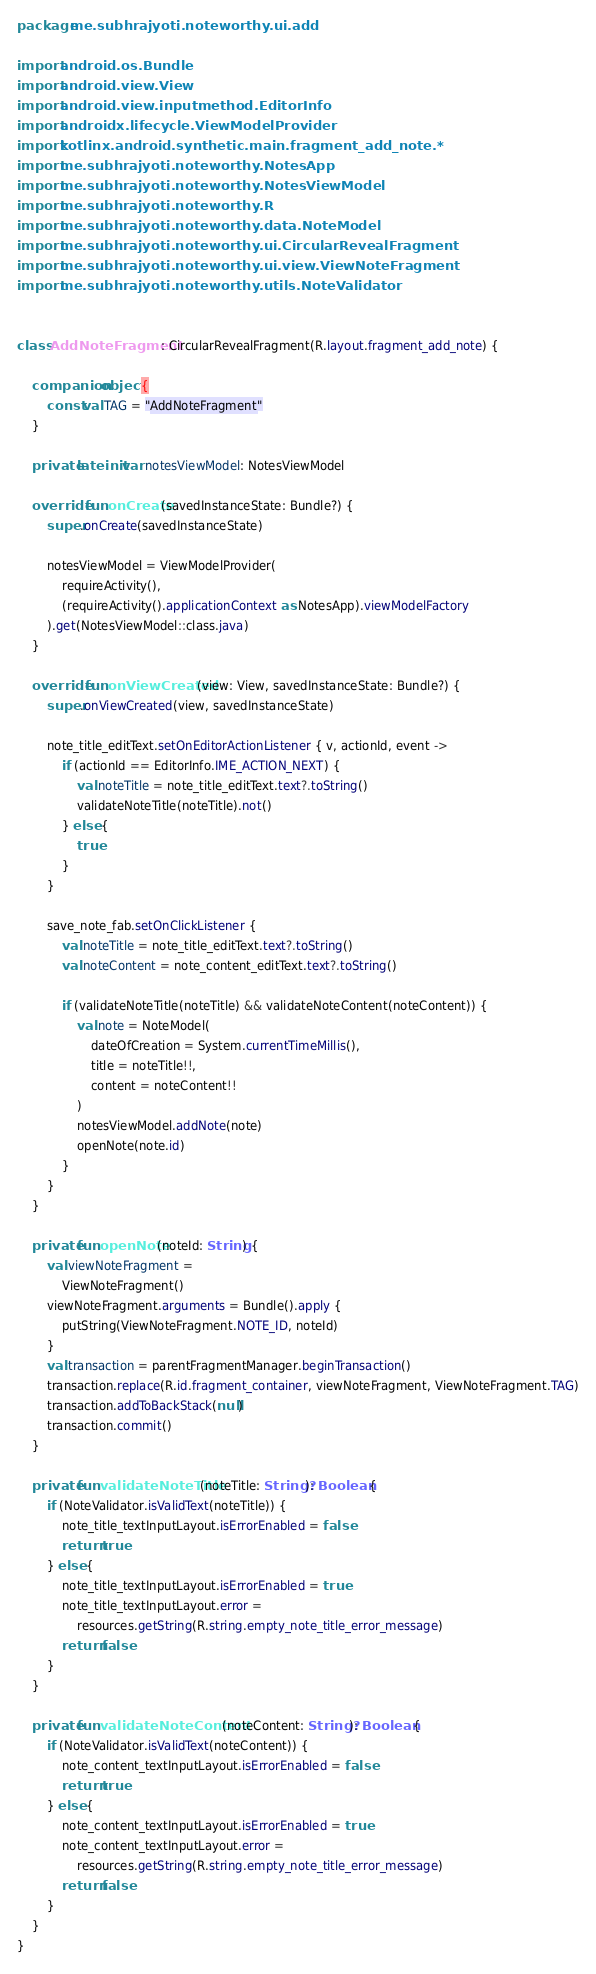Convert code to text. <code><loc_0><loc_0><loc_500><loc_500><_Kotlin_>package me.subhrajyoti.noteworthy.ui.add

import android.os.Bundle
import android.view.View
import android.view.inputmethod.EditorInfo
import androidx.lifecycle.ViewModelProvider
import kotlinx.android.synthetic.main.fragment_add_note.*
import me.subhrajyoti.noteworthy.NotesApp
import me.subhrajyoti.noteworthy.NotesViewModel
import me.subhrajyoti.noteworthy.R
import me.subhrajyoti.noteworthy.data.NoteModel
import me.subhrajyoti.noteworthy.ui.CircularRevealFragment
import me.subhrajyoti.noteworthy.ui.view.ViewNoteFragment
import me.subhrajyoti.noteworthy.utils.NoteValidator


class AddNoteFragment : CircularRevealFragment(R.layout.fragment_add_note) {

    companion object {
        const val TAG = "AddNoteFragment"
    }

    private lateinit var notesViewModel: NotesViewModel

    override fun onCreate(savedInstanceState: Bundle?) {
        super.onCreate(savedInstanceState)

        notesViewModel = ViewModelProvider(
            requireActivity(),
            (requireActivity().applicationContext as NotesApp).viewModelFactory
        ).get(NotesViewModel::class.java)
    }

    override fun onViewCreated(view: View, savedInstanceState: Bundle?) {
        super.onViewCreated(view, savedInstanceState)

        note_title_editText.setOnEditorActionListener { v, actionId, event ->
            if (actionId == EditorInfo.IME_ACTION_NEXT) {
                val noteTitle = note_title_editText.text?.toString()
                validateNoteTitle(noteTitle).not()
            } else {
                true
            }
        }

        save_note_fab.setOnClickListener {
            val noteTitle = note_title_editText.text?.toString()
            val noteContent = note_content_editText.text?.toString()

            if (validateNoteTitle(noteTitle) && validateNoteContent(noteContent)) {
                val note = NoteModel(
                    dateOfCreation = System.currentTimeMillis(),
                    title = noteTitle!!,
                    content = noteContent!!
                )
                notesViewModel.addNote(note)
                openNote(note.id)
            }
        }
    }

    private fun openNote(noteId: String) {
        val viewNoteFragment =
            ViewNoteFragment()
        viewNoteFragment.arguments = Bundle().apply {
            putString(ViewNoteFragment.NOTE_ID, noteId)
        }
        val transaction = parentFragmentManager.beginTransaction()
        transaction.replace(R.id.fragment_container, viewNoteFragment, ViewNoteFragment.TAG)
        transaction.addToBackStack(null)
        transaction.commit()
    }

    private fun validateNoteTitle(noteTitle: String?): Boolean {
        if (NoteValidator.isValidText(noteTitle)) {
            note_title_textInputLayout.isErrorEnabled = false
            return true
        } else {
            note_title_textInputLayout.isErrorEnabled = true
            note_title_textInputLayout.error =
                resources.getString(R.string.empty_note_title_error_message)
            return false
        }
    }

    private fun validateNoteContent(noteContent: String?): Boolean {
        if (NoteValidator.isValidText(noteContent)) {
            note_content_textInputLayout.isErrorEnabled = false
            return true
        } else {
            note_content_textInputLayout.isErrorEnabled = true
            note_content_textInputLayout.error =
                resources.getString(R.string.empty_note_title_error_message)
            return false
        }
    }
}</code> 